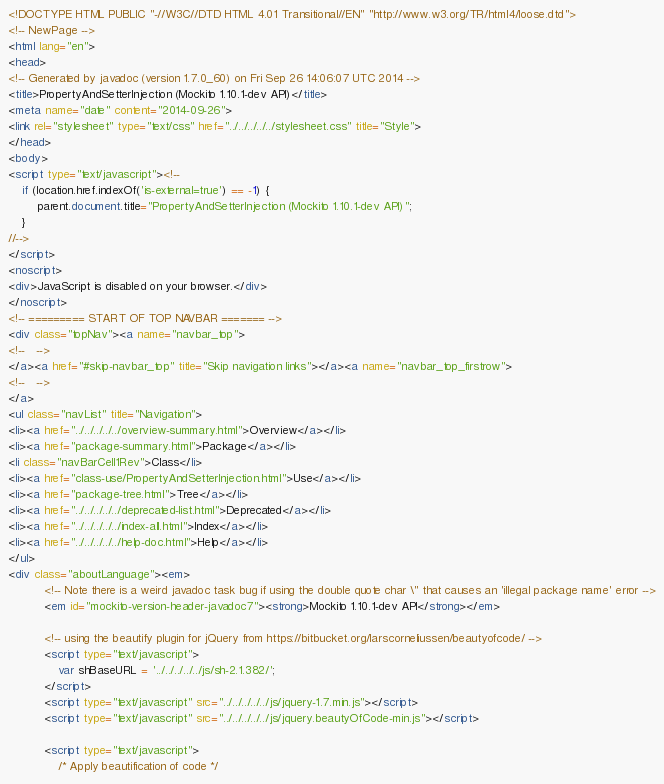Convert code to text. <code><loc_0><loc_0><loc_500><loc_500><_HTML_><!DOCTYPE HTML PUBLIC "-//W3C//DTD HTML 4.01 Transitional//EN" "http://www.w3.org/TR/html4/loose.dtd">
<!-- NewPage -->
<html lang="en">
<head>
<!-- Generated by javadoc (version 1.7.0_60) on Fri Sep 26 14:06:07 UTC 2014 -->
<title>PropertyAndSetterInjection (Mockito 1.10.1-dev API)</title>
<meta name="date" content="2014-09-26">
<link rel="stylesheet" type="text/css" href="../../../../../stylesheet.css" title="Style">
</head>
<body>
<script type="text/javascript"><!--
    if (location.href.indexOf('is-external=true') == -1) {
        parent.document.title="PropertyAndSetterInjection (Mockito 1.10.1-dev API)";
    }
//-->
</script>
<noscript>
<div>JavaScript is disabled on your browser.</div>
</noscript>
<!-- ========= START OF TOP NAVBAR ======= -->
<div class="topNav"><a name="navbar_top">
<!--   -->
</a><a href="#skip-navbar_top" title="Skip navigation links"></a><a name="navbar_top_firstrow">
<!--   -->
</a>
<ul class="navList" title="Navigation">
<li><a href="../../../../../overview-summary.html">Overview</a></li>
<li><a href="package-summary.html">Package</a></li>
<li class="navBarCell1Rev">Class</li>
<li><a href="class-use/PropertyAndSetterInjection.html">Use</a></li>
<li><a href="package-tree.html">Tree</a></li>
<li><a href="../../../../../deprecated-list.html">Deprecated</a></li>
<li><a href="../../../../../index-all.html">Index</a></li>
<li><a href="../../../../../help-doc.html">Help</a></li>
</ul>
<div class="aboutLanguage"><em>
          <!-- Note there is a weird javadoc task bug if using the double quote char \" that causes an 'illegal package name' error -->
          <em id="mockito-version-header-javadoc7"><strong>Mockito 1.10.1-dev API</strong></em>

          <!-- using the beautify plugin for jQuery from https://bitbucket.org/larscorneliussen/beautyofcode/ -->
          <script type="text/javascript">
              var shBaseURL = '../../../../../js/sh-2.1.382/';
          </script>
          <script type="text/javascript" src="../../../../../js/jquery-1.7.min.js"></script>
          <script type="text/javascript" src="../../../../../js/jquery.beautyOfCode-min.js"></script>

          <script type="text/javascript">
              /* Apply beautification of code */</code> 